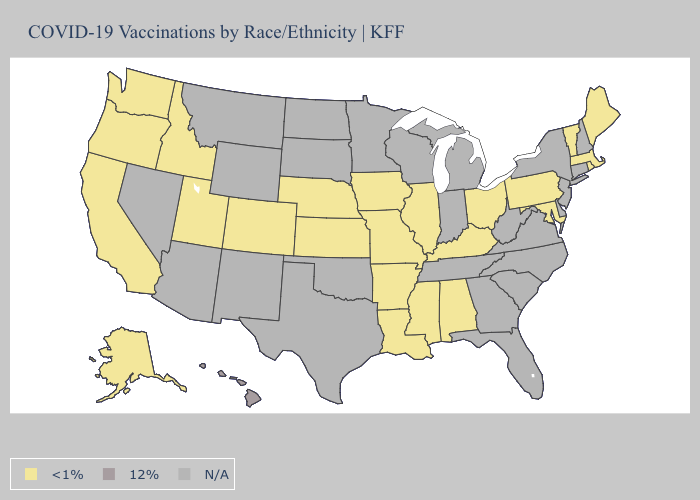What is the lowest value in the USA?
Be succinct. <1%. Which states have the lowest value in the West?
Concise answer only. Alaska, California, Colorado, Idaho, Oregon, Utah, Washington. What is the lowest value in the Northeast?
Quick response, please. <1%. What is the highest value in states that border New Mexico?
Keep it brief. <1%. Name the states that have a value in the range 12%?
Answer briefly. Hawaii. What is the highest value in the USA?
Give a very brief answer. 12%. Does Utah have the highest value in the USA?
Write a very short answer. No. What is the lowest value in the MidWest?
Short answer required. <1%. Which states have the lowest value in the Northeast?
Write a very short answer. Maine, Massachusetts, Pennsylvania, Rhode Island, Vermont. Is the legend a continuous bar?
Be succinct. No. Name the states that have a value in the range N/A?
Give a very brief answer. Arizona, Connecticut, Delaware, Florida, Georgia, Indiana, Michigan, Minnesota, Montana, Nevada, New Hampshire, New Jersey, New Mexico, New York, North Carolina, North Dakota, Oklahoma, South Carolina, South Dakota, Tennessee, Texas, Virginia, West Virginia, Wisconsin, Wyoming. What is the highest value in states that border Georgia?
Write a very short answer. <1%. 